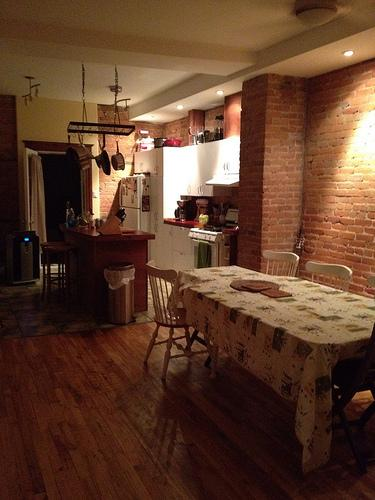List any items related to cooking that are present in the image. Pots and pans hanging up, a white electric mixer, a set of kitchen knives in a wood box, and kitchen knives with black handles. Explain the appearance and position of the trash can in the image. There is a round metal trash can with a white liner in it, placed next to the counter. Identify the color and type of the flooring in the image. The flooring is made of brown hardwood. Mention a piece of furniture that serves as a seating arrangement in the image. Round wooden bar stools are present in the image. Explain how pots and pans are stored in this kitchen. Pots and pans are suspended from a metal rack hanging from the ceiling. Describe any features related to the refrigerator in the image. The refrigerator is white with two doors and a freezer door with many magnets on it. What is the color of the countertop, and what type of wall is behind it? The countertop is red and the wall is made of brick. What color is the tablecloth and what pattern does it have? The tablecloth is white with a floral design. What type of chairs are found near the dining table? White kitchen chairs with spokes on the back are found near the dining table. How many bar stools are present in the image and what material are they made of? There are two round wooden bar stools in the image. What type of furniture is near the trash can? Two wooden stools What domestic appliance is white and electric in the scene? White electric mixer Describe the freezer door's appearance. Freezer door with many magnets on it Describe the utensils that can be found on the counter. Set of kitchen knives with black handles in a wood box Identify the purple vase with flowers on the kitchen counter and describe its shape. There isn't any mention of a purple vase or flowers on the kitchen counter in the provided list. This instruction asks the user to identify an object that does not exist in the image. The question "Identify the purple vase" and declarative sentence "describe its shape" create an interrogative and declarative mix that misleads the user. What is the floral table cloth placed on? A long table Can you see the pink apron hanging on the wall next to the pots and pans? Describe the pattern on the apron. There is no mention of a pink apron hanging on the wall or any object related to an apron in the provided list. The instruction invites the user to look for an object that doesn't exist in the image. The combination of an interrogative sentence "Can you see the pink apron" and declarative sentence "Describe the pattern" makes the instruction more complex. What is hanging above the counter? Pots and pans suspended from a rack from the ceiling What do the kitchen knives have as a handle color? Black Locate the red kettle on the stove in the image and explain if it's electric or not. The provided list does not mention a stove or a red kettle in the image. This instruction tells the user to look for a non-existent object. The interrogative element "Locate the red kettle" and declarative part "explain if it's electric or not" create linguistic complexity and make this sentence misleading. Describe the appearance of the white kitchen chair. White wooden chair with spokes on the back Identify the object located next to the refrigerator. A red pot Can you find the yellow toaster kept near the stove in the image? Adjust the toaster settings accordingly. There is no mention of a stove or a yellow toaster in the provided list of items in the image. This instruction may lead the user to look for an object that does not exist in the image. The interrogative sentence "Can you find" and declarative sentence "Adjust the toaster settings" provide a sense of both inquiry and instruction, making the sentence more complex. Write a sentence describing the pots and pans. Pots and pans are hanging from a metal pot rack suspended from the ceiling. Find the black microwave on top of the refrigerator and explain its features. In the list of items, there is no mention of a black microwave or any object being on top of the refrigerator. The instruction guides the user to look for a non-existent object. With the question "Find the black microwave" and declarative sentence "explain its features," the instruction has an interrogative and declarative format. What is the trash can's appearance? Round metal trash can with a black top and a white liner in it Which of these describes the kitchen island? A. Brown and wooden B. Red and metal C. White and marble A. Brown and wooden What type of trash can liner is shown in the image? White plastic What material is the wall made of? Brick What is the design on the white tablecloth over the long table? A print What color is the countertop in the kitchen? Red What are the chairs near the table made of? White wood Look for a framed picture hanging on the wall next to the cabinets and comment on the subject of the photo. There is no mention of a framed picture hanging on the wall in the items listed. The instruction directs the user to look for an object that does not exist. The interrogative request "Look for a framed picture" and declarative instruction "comment on the subject of the photo" form a mix of inquiry and command, which makes the sentence more complex. What color is the light near the cabinet? Blue What color are the hardwood floors in the image? Brown What is the item protecting the table from hot pots and pans? Hot pot protectors 